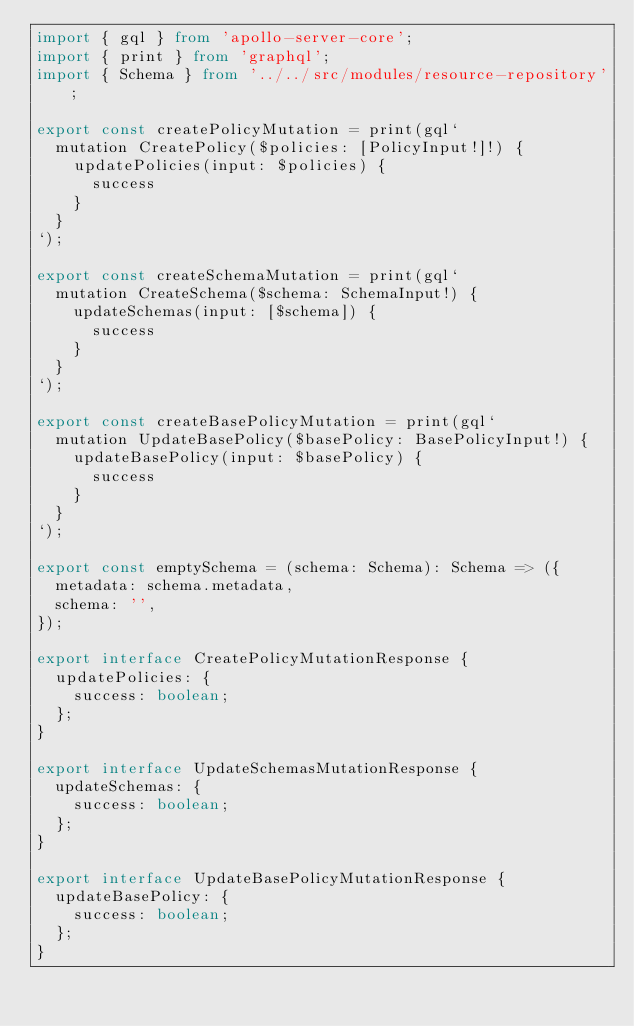Convert code to text. <code><loc_0><loc_0><loc_500><loc_500><_TypeScript_>import { gql } from 'apollo-server-core';
import { print } from 'graphql';
import { Schema } from '../../src/modules/resource-repository';

export const createPolicyMutation = print(gql`
  mutation CreatePolicy($policies: [PolicyInput!]!) {
    updatePolicies(input: $policies) {
      success
    }
  }
`);

export const createSchemaMutation = print(gql`
  mutation CreateSchema($schema: SchemaInput!) {
    updateSchemas(input: [$schema]) {
      success
    }
  }
`);

export const createBasePolicyMutation = print(gql`
  mutation UpdateBasePolicy($basePolicy: BasePolicyInput!) {
    updateBasePolicy(input: $basePolicy) {
      success
    }
  }
`);

export const emptySchema = (schema: Schema): Schema => ({
  metadata: schema.metadata,
  schema: '',
});

export interface CreatePolicyMutationResponse {
  updatePolicies: {
    success: boolean;
  };
}

export interface UpdateSchemasMutationResponse {
  updateSchemas: {
    success: boolean;
  };
}

export interface UpdateBasePolicyMutationResponse {
  updateBasePolicy: {
    success: boolean;
  };
}
</code> 